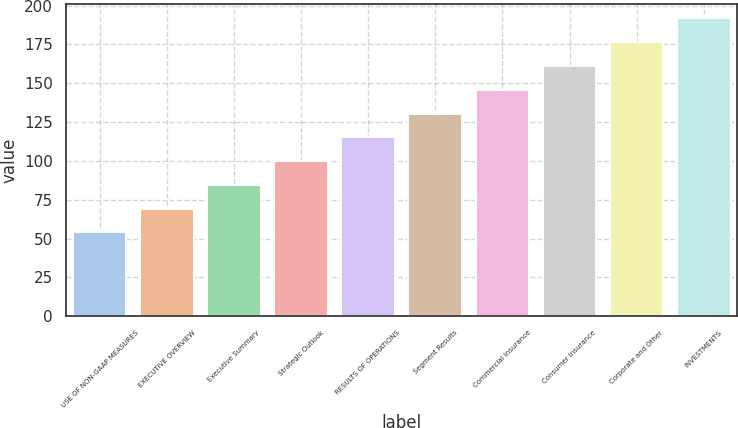Convert chart. <chart><loc_0><loc_0><loc_500><loc_500><bar_chart><fcel>USE OF NON-GAAP MEASURES<fcel>EXECUTIVE OVERVIEW<fcel>Executive Summary<fcel>Strategic Outlook<fcel>RESULTS OF OPERATIONS<fcel>Segment Results<fcel>Commercial Insurance<fcel>Consumer Insurance<fcel>Corporate and Other<fcel>INVESTMENTS<nl><fcel>54<fcel>69.3<fcel>84.6<fcel>99.9<fcel>115.2<fcel>130.5<fcel>145.8<fcel>161.1<fcel>176.4<fcel>191.7<nl></chart> 